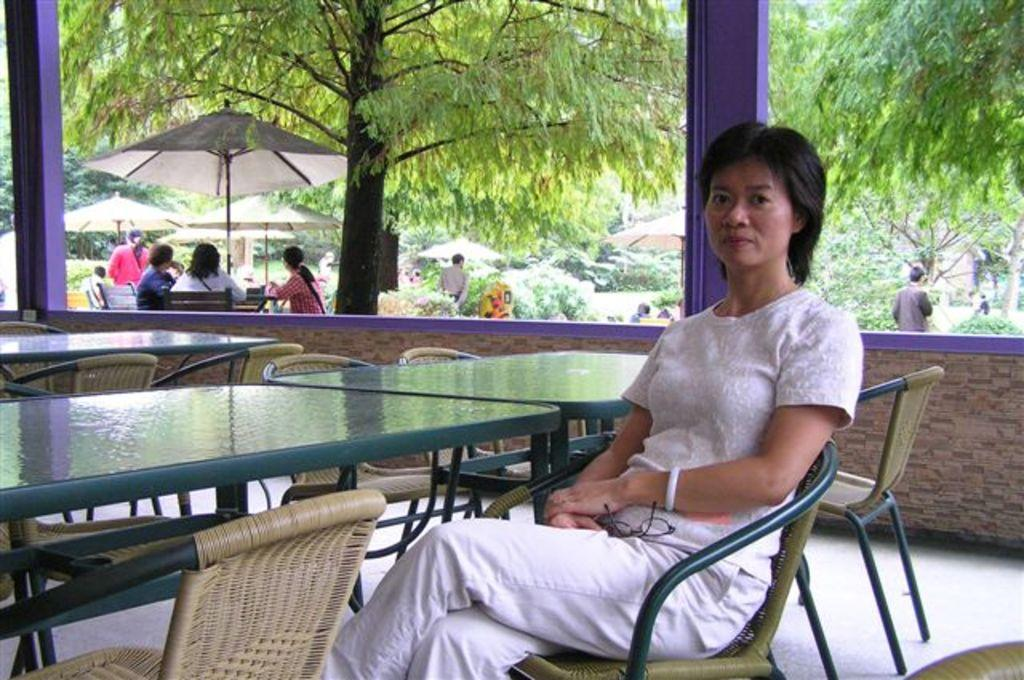How many people are in the image? There are people in the image, but the exact number is not specified. What are some of the people doing in the image? Some people are sitting on chairs, while others are standing. What objects are present in the image that provide shade or protection from the sun? There are umbrellas in the image. What type of natural elements can be seen in the image? There are trees and plants in the image. What type of furniture is present in the image? There are tables in the image. What architectural features are present in the image? There are pillars in the image. Who is the creator of the doll that can be seen in the image? There is no doll present in the image, so it is not possible to determine the creator. 